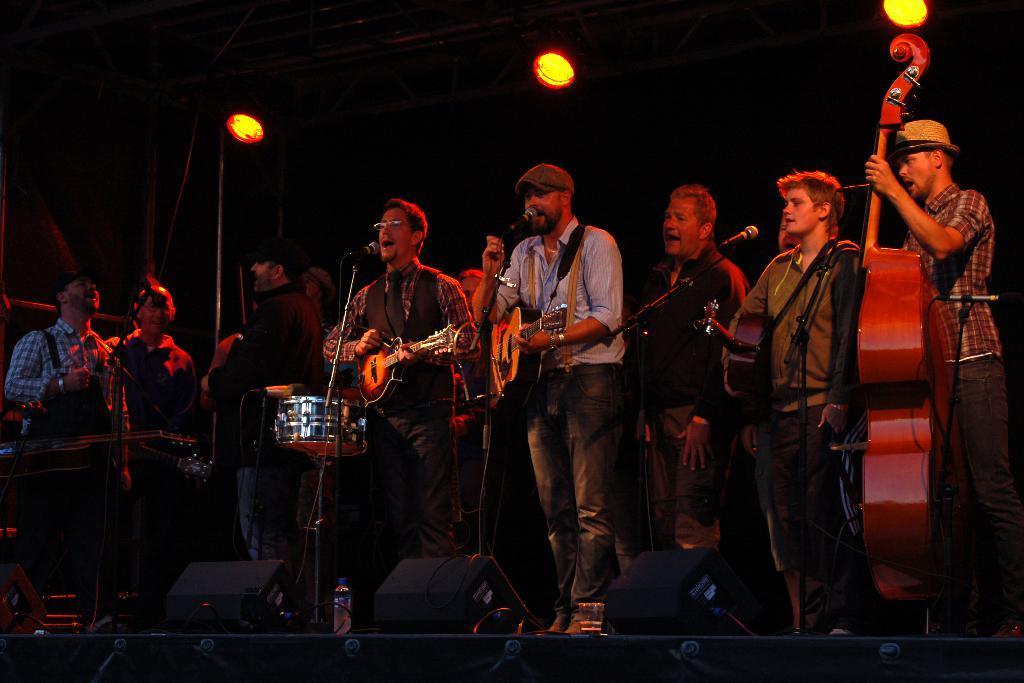Describe this image in one or two sentences. Here we can see a group of people playing their musical instruments and singing with a microphone in front of them 